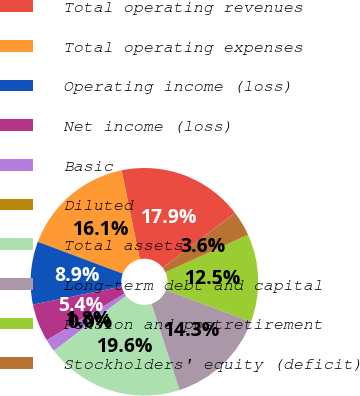Convert chart to OTSL. <chart><loc_0><loc_0><loc_500><loc_500><pie_chart><fcel>Total operating revenues<fcel>Total operating expenses<fcel>Operating income (loss)<fcel>Net income (loss)<fcel>Basic<fcel>Diluted<fcel>Total assets<fcel>Long-term debt and capital<fcel>Pension and postretirement<fcel>Stockholders' equity (deficit)<nl><fcel>17.86%<fcel>16.07%<fcel>8.93%<fcel>5.36%<fcel>1.79%<fcel>0.0%<fcel>19.64%<fcel>14.29%<fcel>12.5%<fcel>3.57%<nl></chart> 